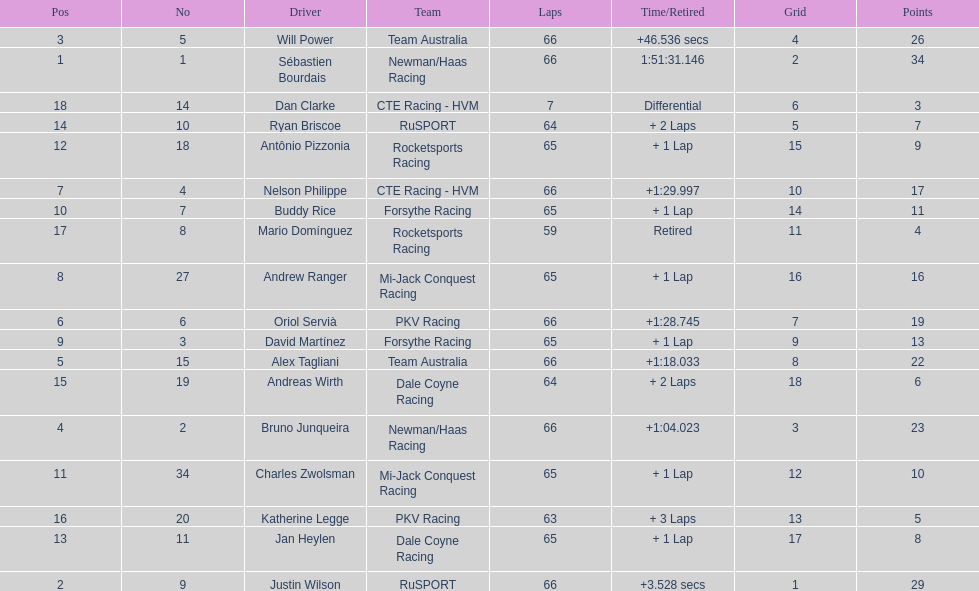Which country had more drivers representing them, the us or germany? Tie. 